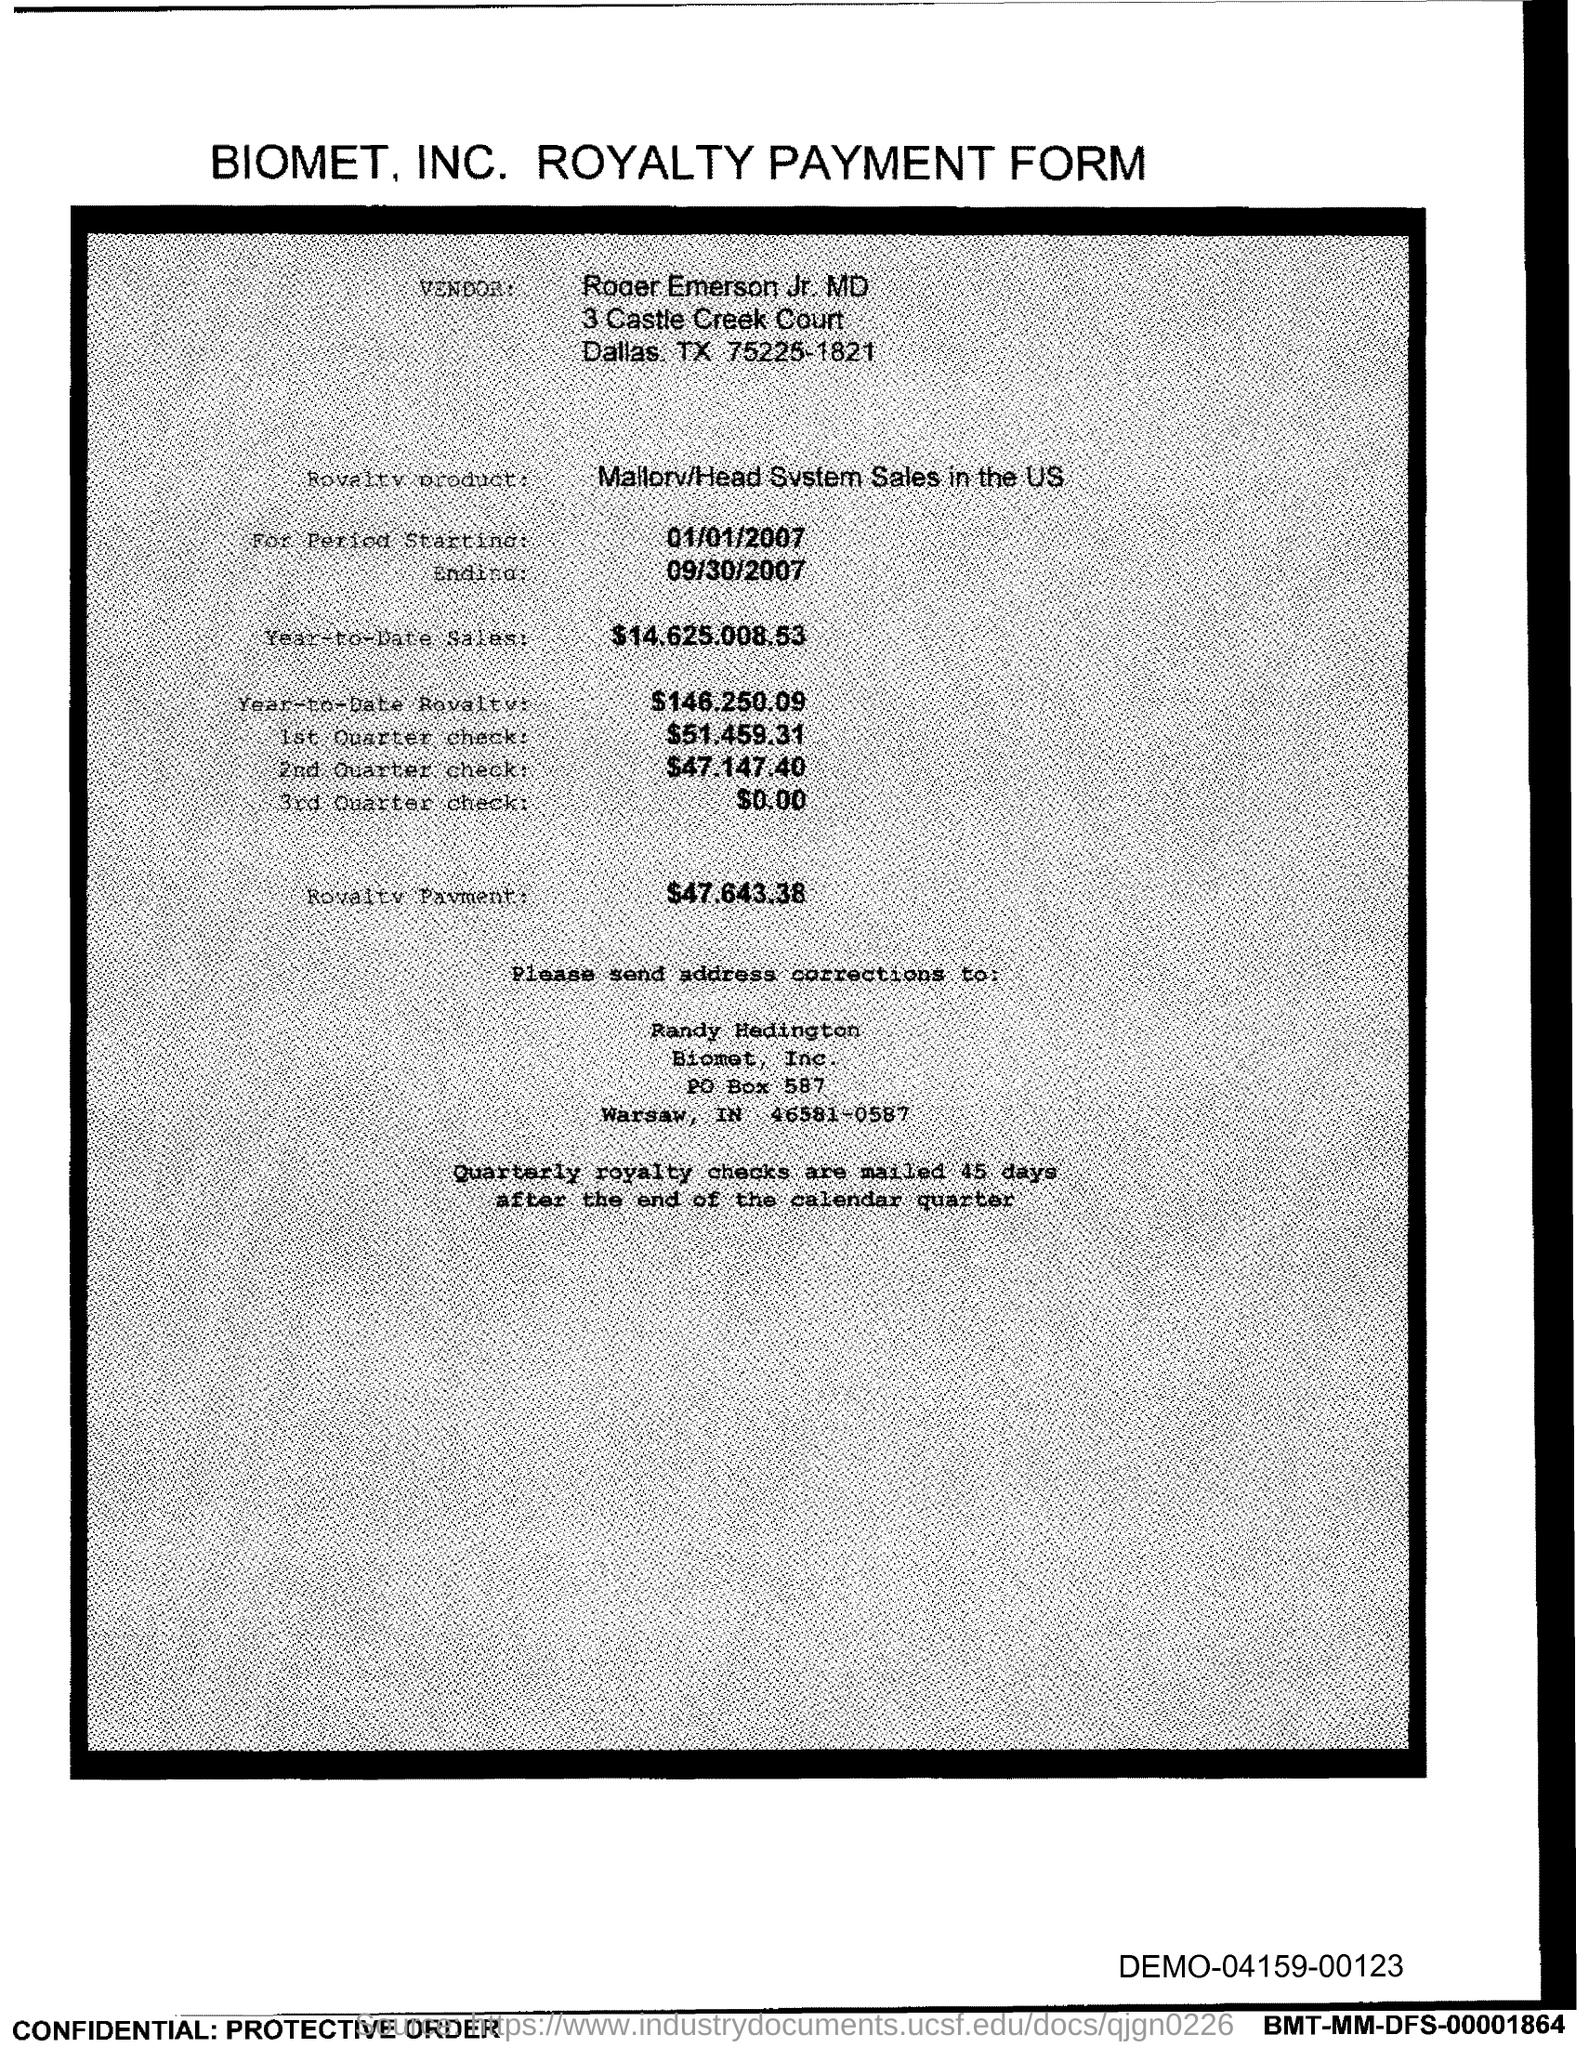Can you tell me the total sales amount by the end of the period? The total sales amount by the end of the period, which is September 30, 2007, is $14,625,008.63. 